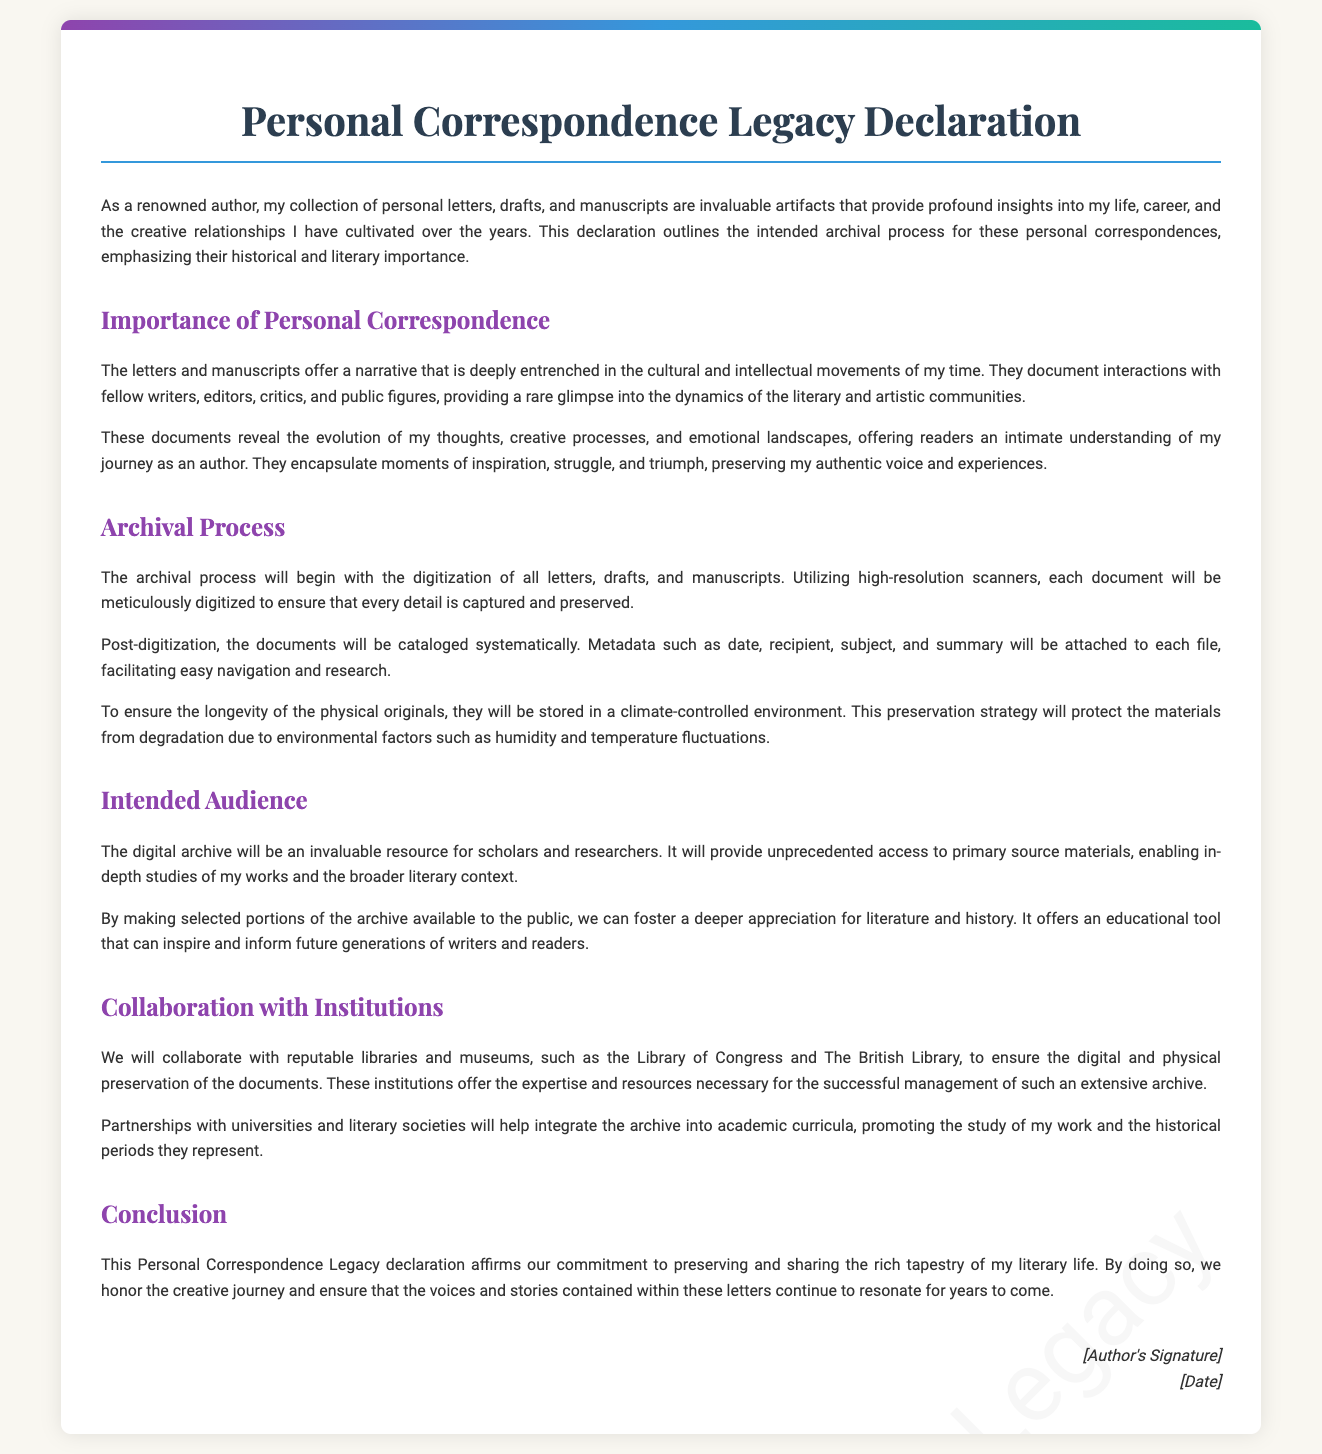What is the title of the declaration? The title is stated prominently at the top of the document, indicating its main focus.
Answer: Personal Correspondence Legacy Declaration Who is the intended audience for the digital archive? The audience is specified in a section that discusses the purpose and access of the archive.
Answer: Scholars and researchers What institutions are mentioned for collaboration? The document lists specific libraries that will play a role in the preservation efforts.
Answer: Library of Congress and The British Library What will be attached to each digitized document? The document mentions a specific type of information that will help in organizing and accessing the archive.
Answer: Metadata What is the main purpose of the Personal Correspondence Legacy declaration? The purpose is articulated in the concluding section, summarizing the overall goal of the document.
Answer: Preserving and sharing the rich tapestry of my literary life How will the physical originals be stored? The method of storage for the physical originals is detailed in the archival process.
Answer: In a climate-controlled environment What will the archival process begin with? The document describes the first step in the archival process precisely.
Answer: Digitization of all letters, drafts, and manuscripts What is emphasized about the letters and manuscripts? The text highlights a specific attribute of the documents that adds to their significance.
Answer: Historical and literary importance How will the archive benefit future generations? The document mentions a specific outcome of making the archive available.
Answer: Inspire and inform future generations of writers and readers 